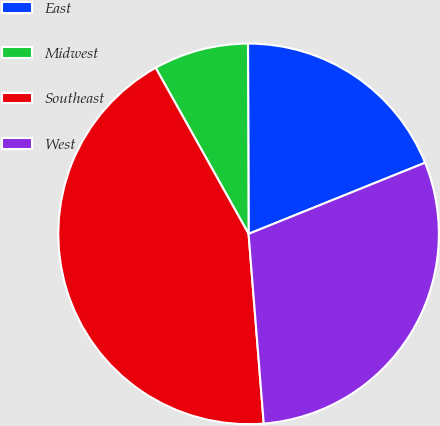Convert chart. <chart><loc_0><loc_0><loc_500><loc_500><pie_chart><fcel>East<fcel>Midwest<fcel>Southeast<fcel>West<nl><fcel>18.95%<fcel>8.07%<fcel>43.15%<fcel>29.83%<nl></chart> 